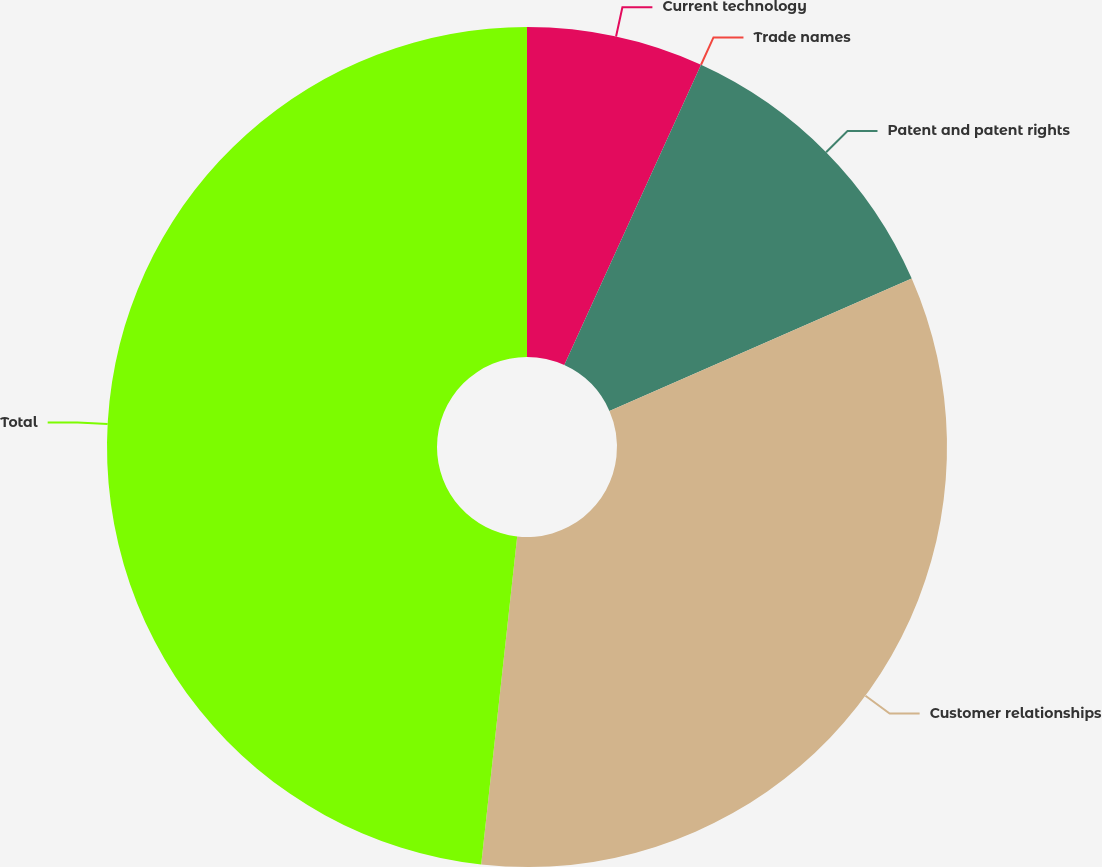Convert chart to OTSL. <chart><loc_0><loc_0><loc_500><loc_500><pie_chart><fcel>Current technology<fcel>Trade names<fcel>Patent and patent rights<fcel>Customer relationships<fcel>Total<nl><fcel>6.8%<fcel>0.0%<fcel>11.63%<fcel>33.31%<fcel>48.26%<nl></chart> 